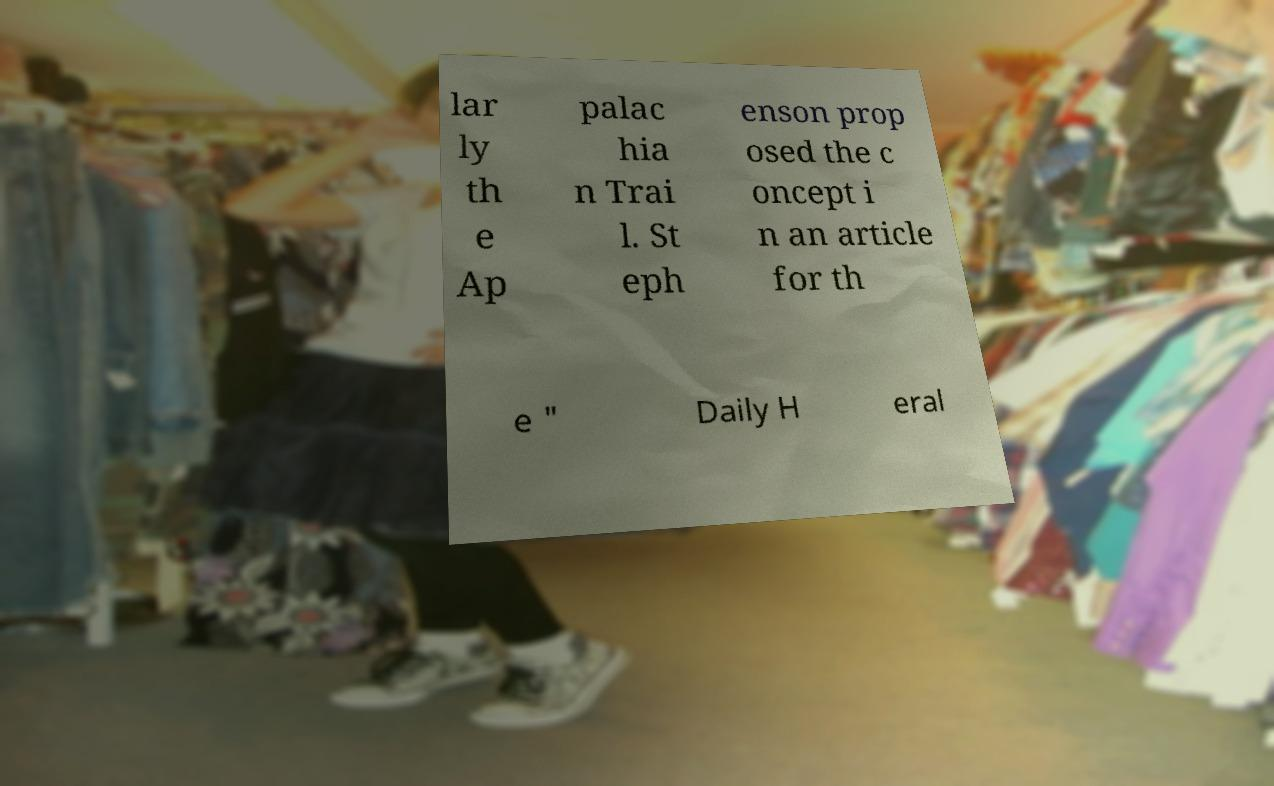What messages or text are displayed in this image? I need them in a readable, typed format. lar ly th e Ap palac hia n Trai l. St eph enson prop osed the c oncept i n an article for th e " Daily H eral 